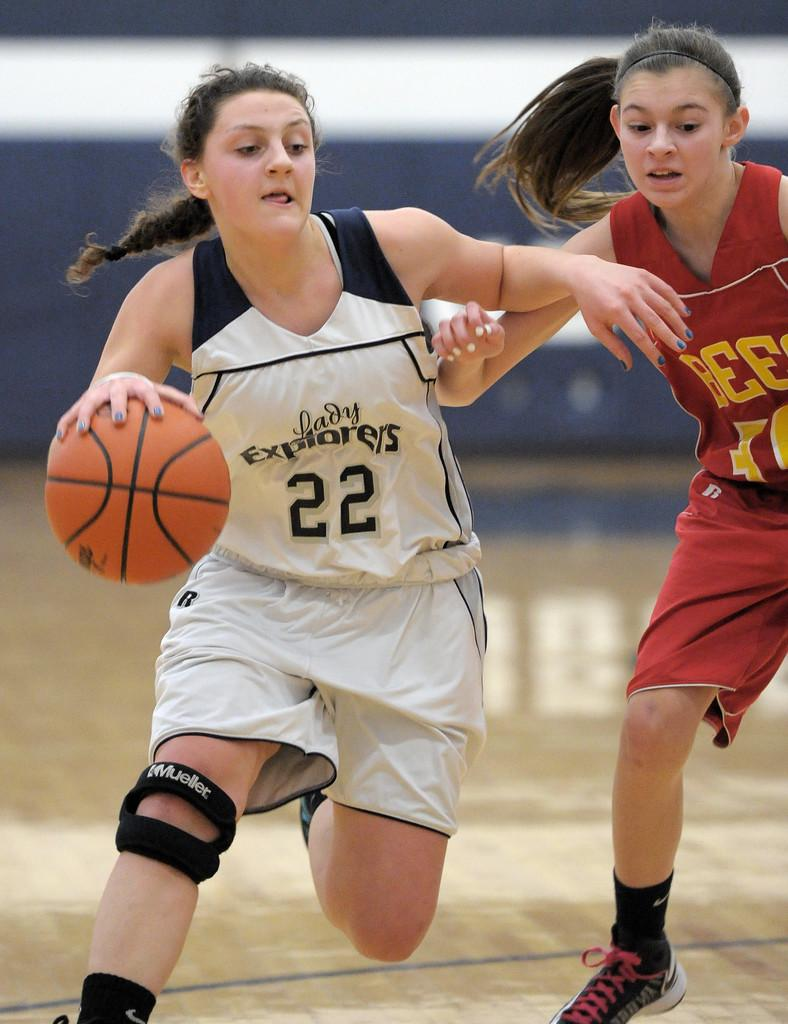<image>
Share a concise interpretation of the image provided. Lady Explorers number 22 wore a knee brace during a recent game. 